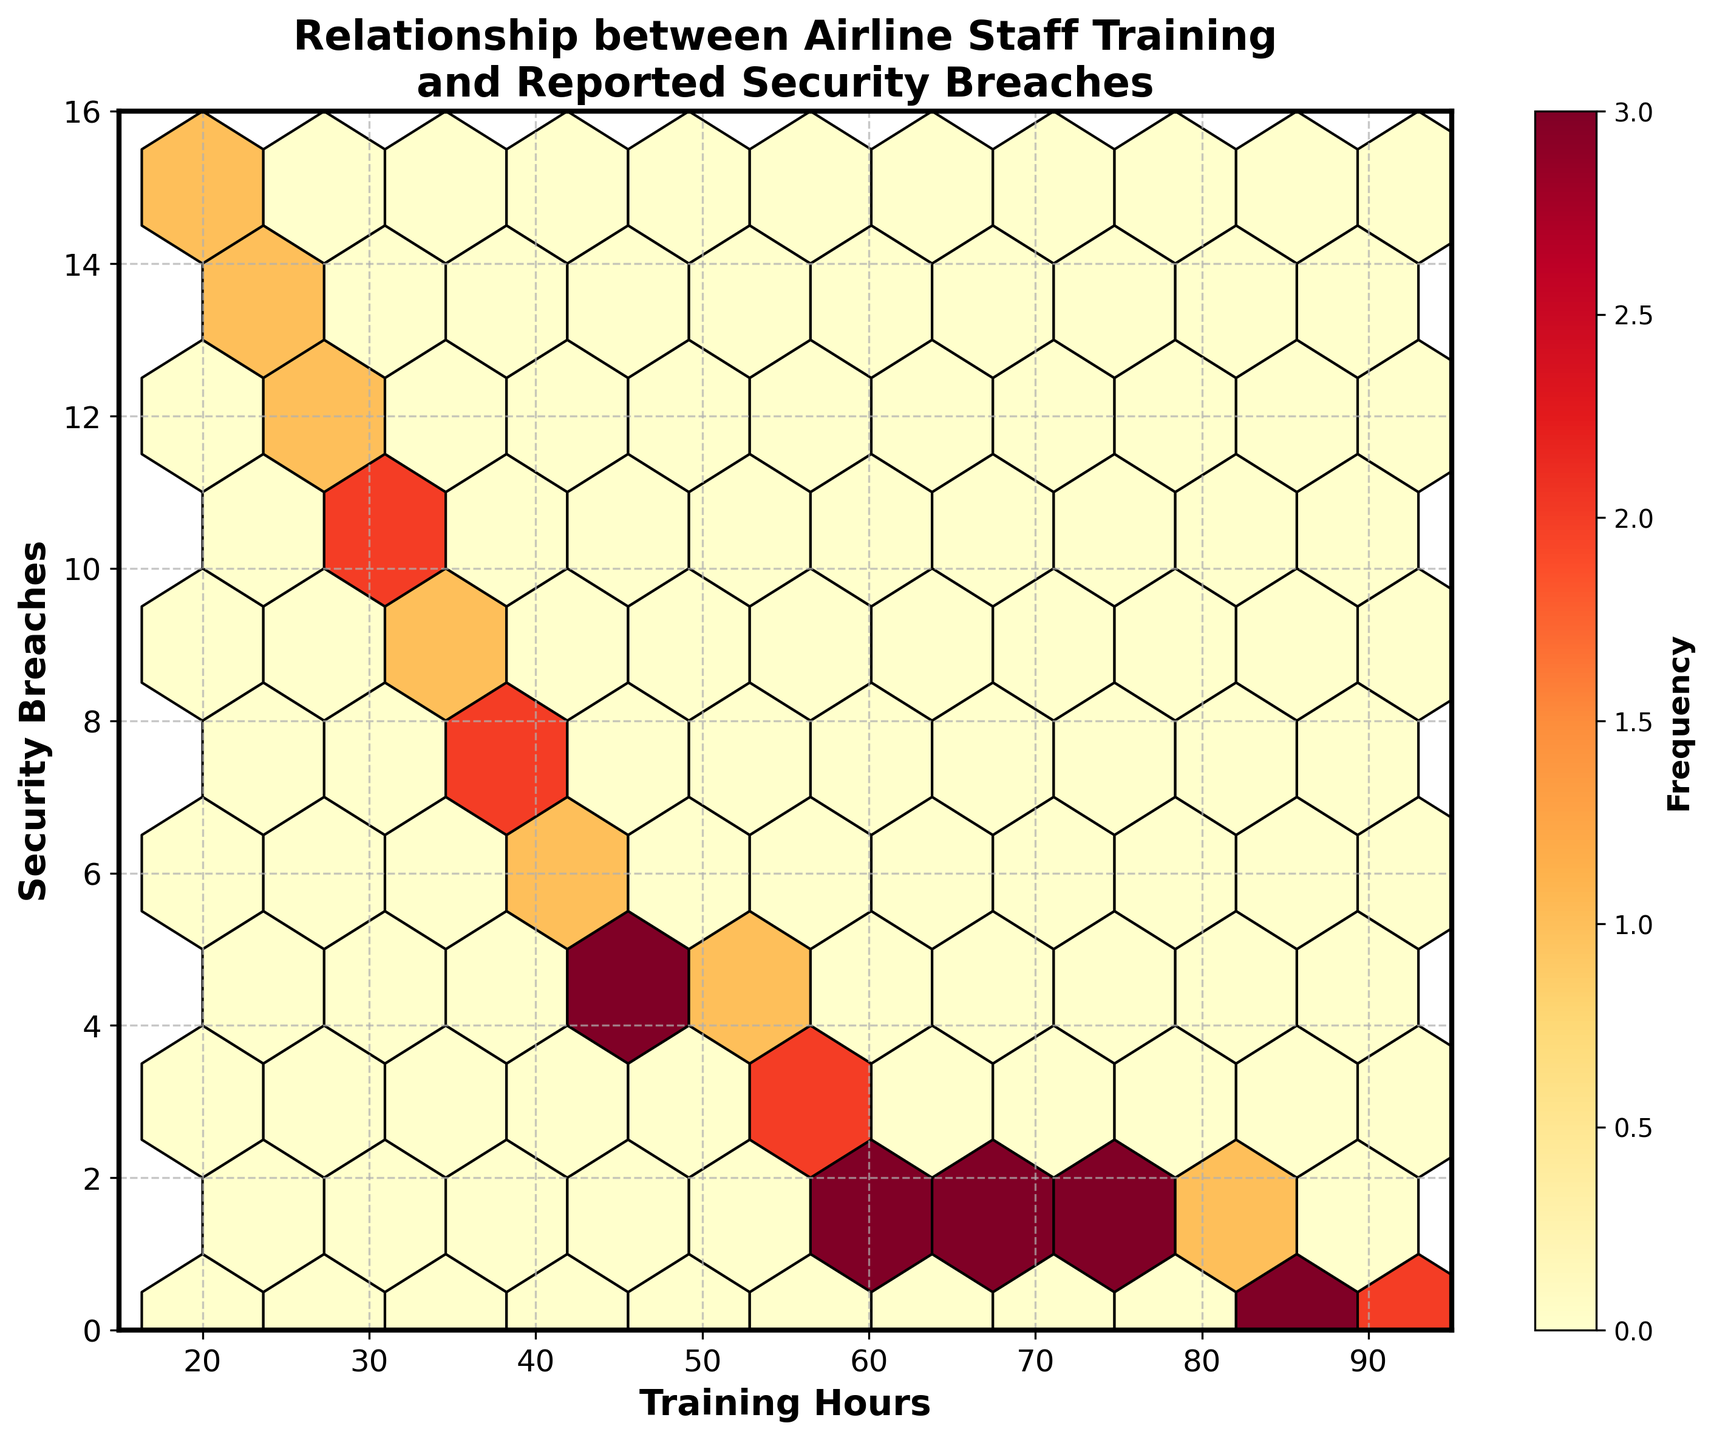What is the relationship being explored in this hexbin plot? The hexbin plot examines the relationship between airline staff training hours (x-axis) and reported security breaches (y-axis). The plot's title and labeled axes make this clear.
Answer: The relationship between airline staff training hours and security breaches Which color scheme is used in this hexbin plot to display the frequency of data points? The plot uses a color scheme ranging from yellow to red (YlOrRd), where lighter colors represent lower frequencies and darker colors represent higher frequencies.
Answer: Yellow to Red (YlOrRd) What is the range of training hours displayed on the x-axis? The x-axis shows training hours ranging from 15 to 95 hours. This can be seen directly by observing the axis limits.
Answer: 15 to 95 hours How many distinct clusters of data points can be seen in the hexbin plot? Observing the hexbin plot, there appears to be a distinct cluster of data points around the 20-40 training hours range and another around the 50-70 training hours range, with decreasing security breaches.
Answer: Two distinct clusters What is the color of the region with the highest frequency of data points, and what does it signify? The region with the highest frequency of data points is the darkest red, indicating a higher concentration of data points (higher frequency) at that location.
Answer: Darkest Red, highest frequency Comparing the hexagons representing 20 and 40 training hours, which one tends to show higher frequencies for security breaches, and what might this suggest? The 20 training hours hexagons tend to show higher frequencies for security breaches than the 40 training hour hexagons. This suggests that fewer training hours are associated with more security breaches.
Answer: 20 training hours have higher frequencies for security breaches Does an increase in training hours appear to be associated with a decrease in reported security breaches? Specifically, how do security breaches compare at the 30 training hours mark versus the 70 training hours mark? Security breaches decrease as training hours increase. At 30 hours, security breaches are around 10, while at 70 hours, breaches drop to about 1, indicating a negative correlation.
Answer: Decrease; 30 hours ~ 10 breaches, 70 hours ~ 1 breach At what training hours value do the security breaches first drop to zero, according to the hexbin plot? The hexbin plot shows security breaches first dropping to zero at around 85 training hours.
Answer: 85 training hours What is the frequency range shown in the color bar on the right side of the hexbin plot? The color bar on the right side of the hexbin plot indicates frequency ranges from low (yellow) to high (dark red), represented numerically typically starting from 1 (minimum) upwards.
Answer: Low to high, starting from 1 